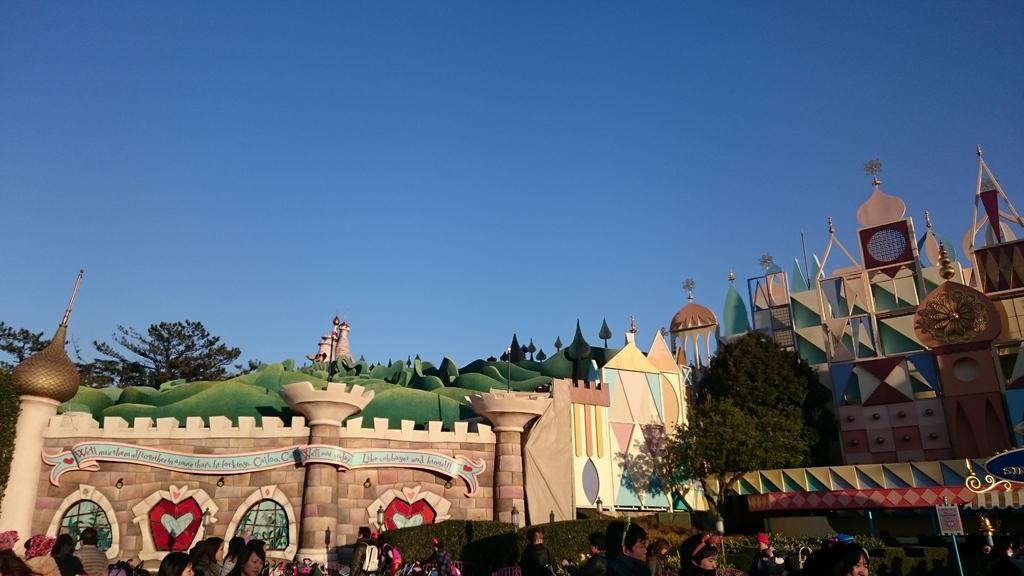Please provide a concise description of this image. In this image we can see castle, trees, person's, name board. In the background there is sky. 